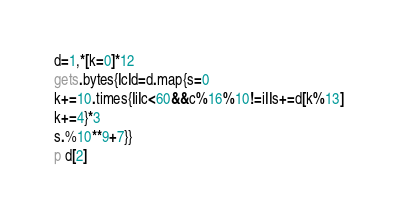<code> <loc_0><loc_0><loc_500><loc_500><_Ruby_>d=1,*[k=0]*12
gets.bytes{|c|d=d.map{s=0
k+=10.times{|i|c<60&&c%16%10!=i||s+=d[k%13]
k+=4}*3
s.%10**9+7}}
p d[2]</code> 